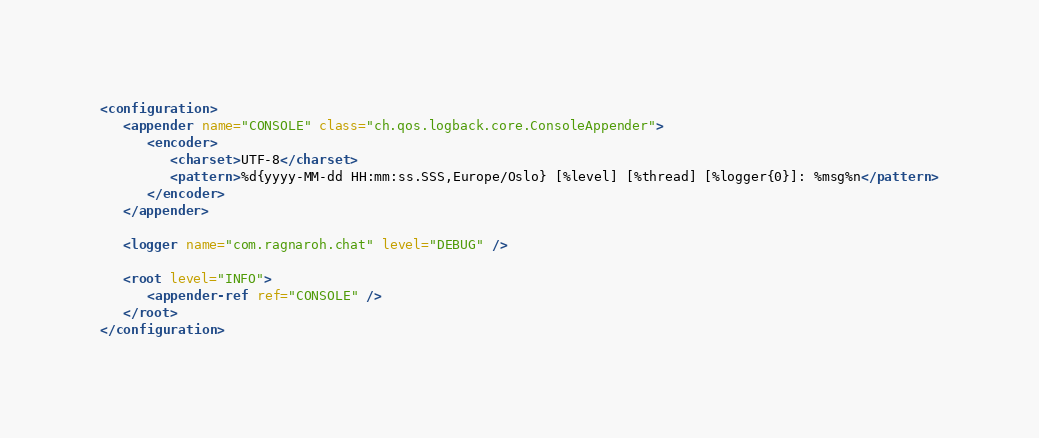Convert code to text. <code><loc_0><loc_0><loc_500><loc_500><_XML_><configuration>
   <appender name="CONSOLE" class="ch.qos.logback.core.ConsoleAppender">
      <encoder>
         <charset>UTF-8</charset>
         <pattern>%d{yyyy-MM-dd HH:mm:ss.SSS,Europe/Oslo} [%level] [%thread] [%logger{0}]: %msg%n</pattern>
      </encoder>
   </appender>

   <logger name="com.ragnaroh.chat" level="DEBUG" />

   <root level="INFO">
      <appender-ref ref="CONSOLE" />
   </root>
</configuration>
</code> 